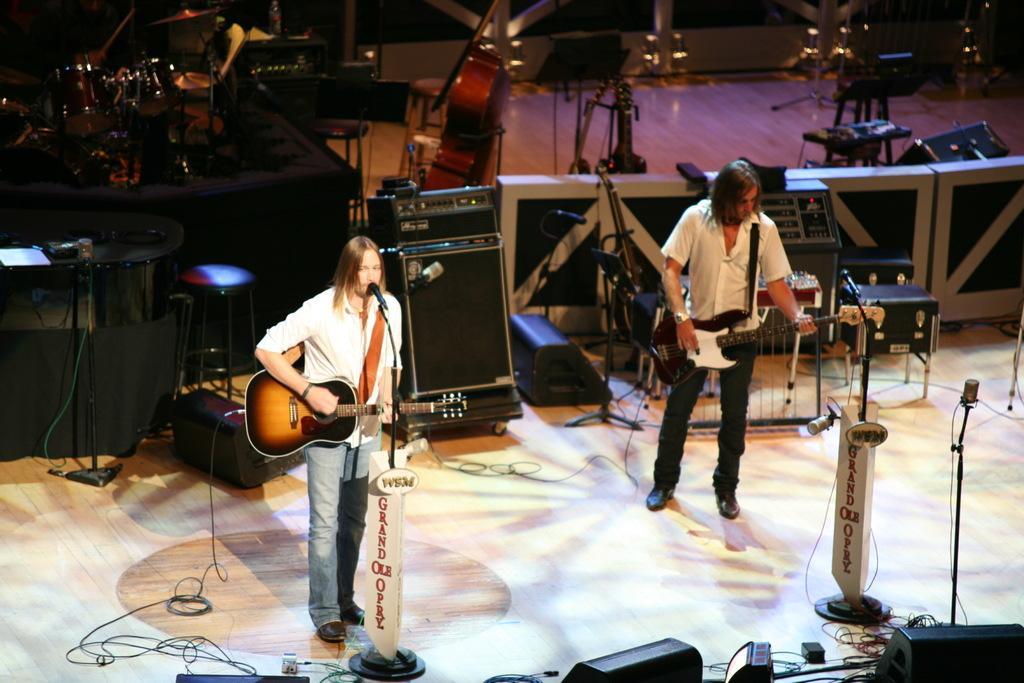Can you describe this image briefly? In the middle of the image a man standing and playing guitar and singing. In the middle of the image a man is standing and playing guitar. Bottom right side of the image there is a microphone. Top left side of the image there is a drum. In the middle of the image there are some musical instruments. 